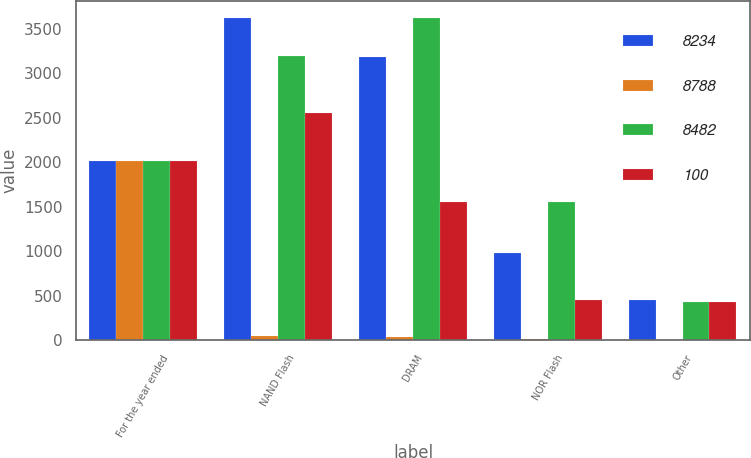Convert chart. <chart><loc_0><loc_0><loc_500><loc_500><stacked_bar_chart><ecel><fcel>For the year ended<fcel>NAND Flash<fcel>DRAM<fcel>NOR Flash<fcel>Other<nl><fcel>8234<fcel>2012<fcel>3627<fcel>3178<fcel>977<fcel>452<nl><fcel>8788<fcel>2012<fcel>44<fcel>39<fcel>12<fcel>5<nl><fcel>8482<fcel>2011<fcel>3193<fcel>3620<fcel>1547<fcel>428<nl><fcel>100<fcel>2010<fcel>2555<fcel>1547<fcel>451<fcel>424<nl></chart> 